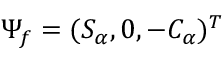<formula> <loc_0><loc_0><loc_500><loc_500>\Psi _ { f } = ( S _ { \alpha } , 0 , - C _ { \alpha } ) ^ { T }</formula> 